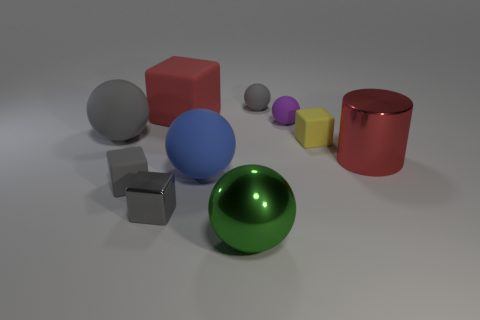Subtract all purple spheres. How many spheres are left? 4 Subtract all green metallic balls. How many balls are left? 4 Subtract all brown balls. Subtract all green cubes. How many balls are left? 5 Subtract all cylinders. How many objects are left? 9 Subtract 0 green cylinders. How many objects are left? 10 Subtract all large gray balls. Subtract all big rubber balls. How many objects are left? 7 Add 7 yellow rubber things. How many yellow rubber things are left? 8 Add 6 small cyan cubes. How many small cyan cubes exist? 6 